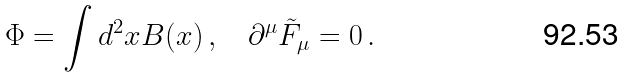<formula> <loc_0><loc_0><loc_500><loc_500>\Phi = \int d ^ { 2 } x B ( x ) \, , \quad \partial ^ { \mu } \tilde { F } _ { \mu } = 0 \, .</formula> 